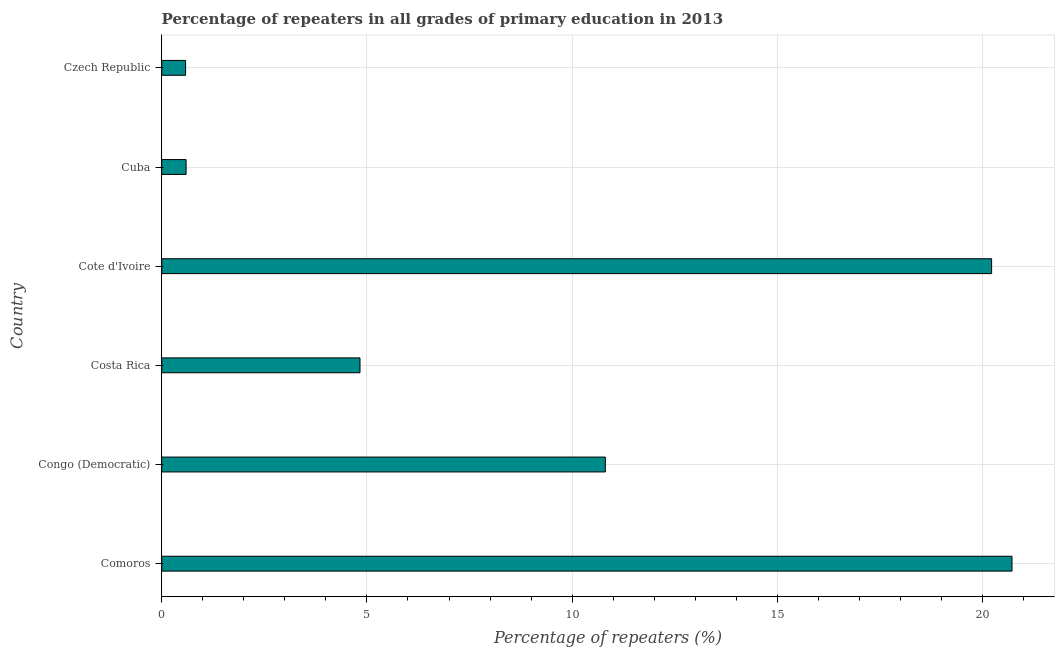Does the graph contain any zero values?
Make the answer very short. No. Does the graph contain grids?
Make the answer very short. Yes. What is the title of the graph?
Give a very brief answer. Percentage of repeaters in all grades of primary education in 2013. What is the label or title of the X-axis?
Make the answer very short. Percentage of repeaters (%). What is the percentage of repeaters in primary education in Czech Republic?
Keep it short and to the point. 0.58. Across all countries, what is the maximum percentage of repeaters in primary education?
Make the answer very short. 20.72. Across all countries, what is the minimum percentage of repeaters in primary education?
Provide a succinct answer. 0.58. In which country was the percentage of repeaters in primary education maximum?
Your answer should be compact. Comoros. In which country was the percentage of repeaters in primary education minimum?
Ensure brevity in your answer.  Czech Republic. What is the sum of the percentage of repeaters in primary education?
Provide a short and direct response. 57.75. What is the difference between the percentage of repeaters in primary education in Congo (Democratic) and Czech Republic?
Make the answer very short. 10.23. What is the average percentage of repeaters in primary education per country?
Provide a succinct answer. 9.62. What is the median percentage of repeaters in primary education?
Your answer should be compact. 7.82. In how many countries, is the percentage of repeaters in primary education greater than 20 %?
Ensure brevity in your answer.  2. What is the ratio of the percentage of repeaters in primary education in Comoros to that in Cote d'Ivoire?
Make the answer very short. 1.02. What is the difference between the highest and the second highest percentage of repeaters in primary education?
Your response must be concise. 0.5. What is the difference between the highest and the lowest percentage of repeaters in primary education?
Your answer should be very brief. 20.13. Are all the bars in the graph horizontal?
Your response must be concise. Yes. How many countries are there in the graph?
Provide a short and direct response. 6. What is the difference between two consecutive major ticks on the X-axis?
Keep it short and to the point. 5. What is the Percentage of repeaters (%) of Comoros?
Provide a short and direct response. 20.72. What is the Percentage of repeaters (%) in Congo (Democratic)?
Keep it short and to the point. 10.81. What is the Percentage of repeaters (%) of Costa Rica?
Your answer should be very brief. 4.83. What is the Percentage of repeaters (%) in Cote d'Ivoire?
Offer a very short reply. 20.22. What is the Percentage of repeaters (%) in Cuba?
Make the answer very short. 0.59. What is the Percentage of repeaters (%) of Czech Republic?
Provide a short and direct response. 0.58. What is the difference between the Percentage of repeaters (%) in Comoros and Congo (Democratic)?
Provide a short and direct response. 9.91. What is the difference between the Percentage of repeaters (%) in Comoros and Costa Rica?
Give a very brief answer. 15.89. What is the difference between the Percentage of repeaters (%) in Comoros and Cote d'Ivoire?
Offer a terse response. 0.5. What is the difference between the Percentage of repeaters (%) in Comoros and Cuba?
Provide a succinct answer. 20.12. What is the difference between the Percentage of repeaters (%) in Comoros and Czech Republic?
Provide a short and direct response. 20.13. What is the difference between the Percentage of repeaters (%) in Congo (Democratic) and Costa Rica?
Offer a terse response. 5.98. What is the difference between the Percentage of repeaters (%) in Congo (Democratic) and Cote d'Ivoire?
Give a very brief answer. -9.41. What is the difference between the Percentage of repeaters (%) in Congo (Democratic) and Cuba?
Your answer should be compact. 10.21. What is the difference between the Percentage of repeaters (%) in Congo (Democratic) and Czech Republic?
Your response must be concise. 10.23. What is the difference between the Percentage of repeaters (%) in Costa Rica and Cote d'Ivoire?
Provide a succinct answer. -15.39. What is the difference between the Percentage of repeaters (%) in Costa Rica and Cuba?
Provide a succinct answer. 4.24. What is the difference between the Percentage of repeaters (%) in Costa Rica and Czech Republic?
Your answer should be very brief. 4.25. What is the difference between the Percentage of repeaters (%) in Cote d'Ivoire and Cuba?
Your answer should be compact. 19.63. What is the difference between the Percentage of repeaters (%) in Cote d'Ivoire and Czech Republic?
Make the answer very short. 19.64. What is the difference between the Percentage of repeaters (%) in Cuba and Czech Republic?
Offer a terse response. 0.01. What is the ratio of the Percentage of repeaters (%) in Comoros to that in Congo (Democratic)?
Provide a succinct answer. 1.92. What is the ratio of the Percentage of repeaters (%) in Comoros to that in Costa Rica?
Make the answer very short. 4.29. What is the ratio of the Percentage of repeaters (%) in Comoros to that in Cote d'Ivoire?
Give a very brief answer. 1.02. What is the ratio of the Percentage of repeaters (%) in Comoros to that in Cuba?
Offer a terse response. 34.88. What is the ratio of the Percentage of repeaters (%) in Comoros to that in Czech Republic?
Offer a terse response. 35.62. What is the ratio of the Percentage of repeaters (%) in Congo (Democratic) to that in Costa Rica?
Give a very brief answer. 2.24. What is the ratio of the Percentage of repeaters (%) in Congo (Democratic) to that in Cote d'Ivoire?
Ensure brevity in your answer.  0.54. What is the ratio of the Percentage of repeaters (%) in Congo (Democratic) to that in Czech Republic?
Your answer should be very brief. 18.59. What is the ratio of the Percentage of repeaters (%) in Costa Rica to that in Cote d'Ivoire?
Your response must be concise. 0.24. What is the ratio of the Percentage of repeaters (%) in Costa Rica to that in Cuba?
Your response must be concise. 8.13. What is the ratio of the Percentage of repeaters (%) in Costa Rica to that in Czech Republic?
Offer a very short reply. 8.31. What is the ratio of the Percentage of repeaters (%) in Cote d'Ivoire to that in Cuba?
Provide a short and direct response. 34.05. What is the ratio of the Percentage of repeaters (%) in Cote d'Ivoire to that in Czech Republic?
Give a very brief answer. 34.77. 